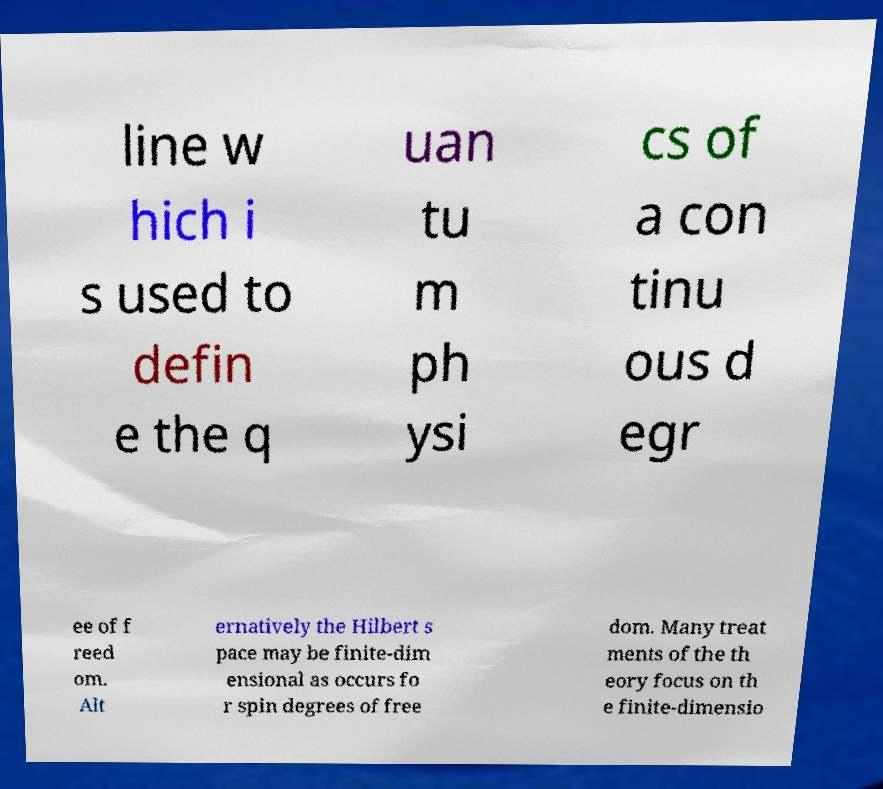I need the written content from this picture converted into text. Can you do that? line w hich i s used to defin e the q uan tu m ph ysi cs of a con tinu ous d egr ee of f reed om. Alt ernatively the Hilbert s pace may be finite-dim ensional as occurs fo r spin degrees of free dom. Many treat ments of the th eory focus on th e finite-dimensio 